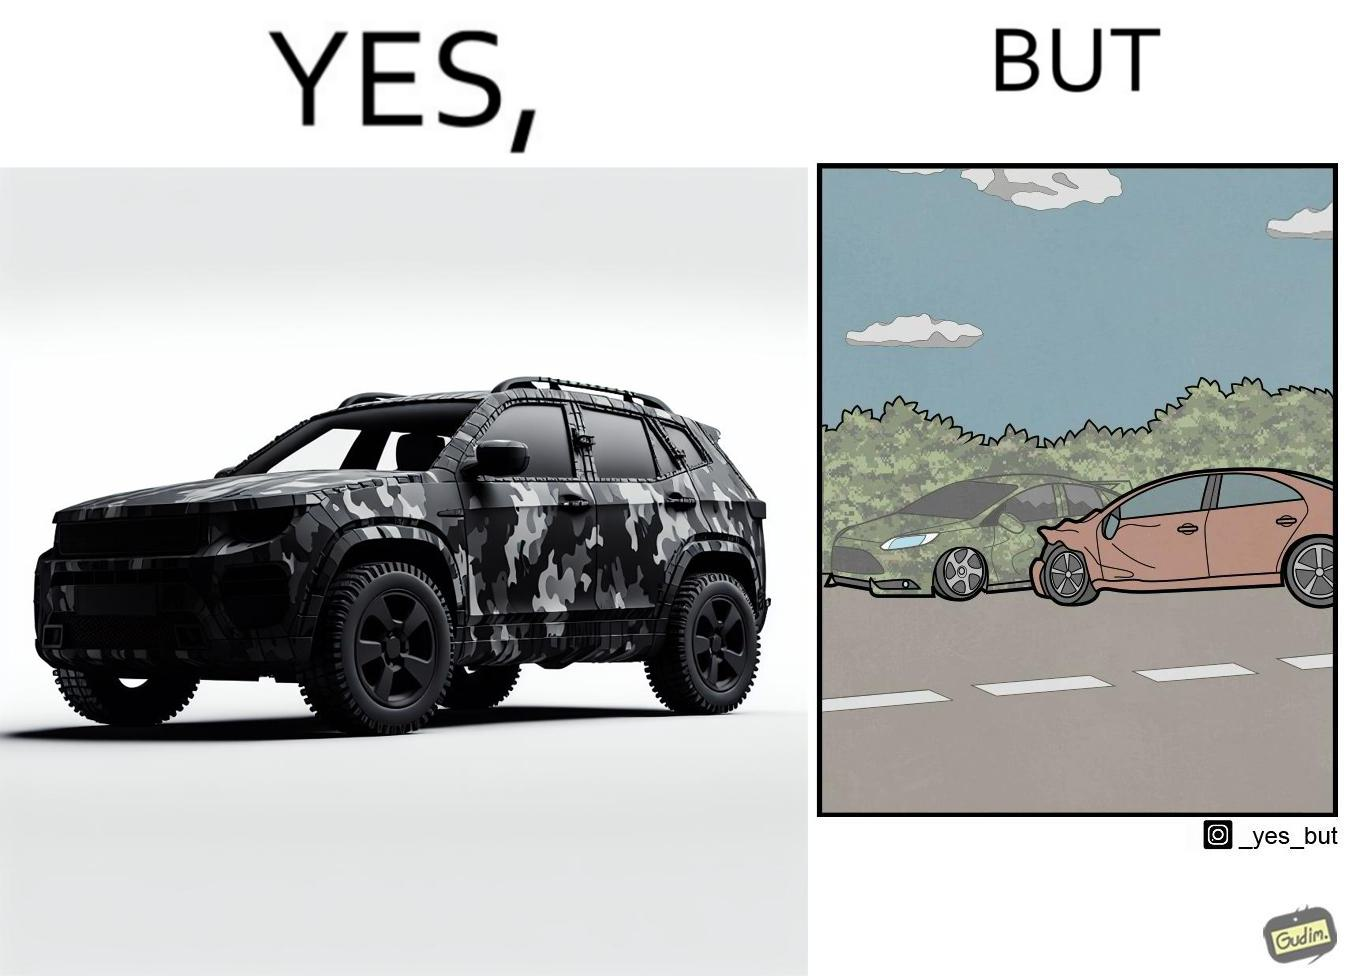Is there satirical content in this image? Yes, this image is satirical. 